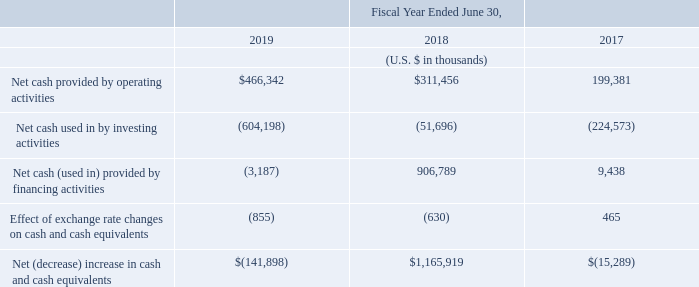B. Liquidity and Capital Resources
As of June 30, 2019, we had cash and cash equivalents totaling $1.3 billion, short-term investments totaling $445.0 million and trade receivables totaling $82.5 million. Since our inception, we have primarily financed our operations through cash flows generated by operations.
Our cash flows from operating activities, investing activities, and financing activities for the fiscal years ended 2019, 2018 and 2017 were as follows:
We believe that our existing cash and cash equivalents, together with cash generated from operations, will be sufficient to meet our anticipated cash needs for at least the next 12 months. Our future capital requirements will depend on many factors including our growth rate, the timing and extent of spend on research and development efforts, employee headcount, marketing and sales activities, acquisitions of additional businesses and technologies, the timing and extent of exchange of the Notes for payments of cash, the introduction of new software and services offerings, enhancements to our existing software and services offerings and the continued market acceptance of our products.
Cash provided by operating activities has historically been affected by the amount of net income (loss) adjusted for non-cash expense items such as non-coupon impact related to the Notes and capped calls, depreciation and amortization and expense associated with share-based awards, the timing of employee-related costs such as bonus payments, collections from our customers, which is our largest source of operating cash flows, and changes in other working capital accounts.
Accounts impacting working capital consist of trade receivables, prepaid expenses and other current assets, current derivative assets, trade and other payables, provisions, current derivative liabilities, current portion of our Notes and other current liabilities. Our working capital may be impacted by various factors in future periods, such as billings to customers for subscriptions, licenses and maintenance services and the subsequent collection of those billings or the amount and timing of certain expenditures.
Net cash provided by operating activities was $466.3 million for the fiscal year ended June 30, 2019, as a result of $605.6 million in loss before income tax expense adjusted by non-cash charges including the loss of marking to fair value of the embedded exchange feature of the Notes and related capped call transactions of $533.9 million, depreciation and amortization of $70.2 million, share-based payment expense of $257.8 million and debt discount and issuance cost amortization of $33.9 million. The net increase of $169.0 million from our operating assets and liabilities was primarily attributable to a $122.5 million increase in our deferred revenue as a result of increased sales of subscriptions and renewals of maintenance contracts and a $75.6 million increase in trade and other payables, provisions and other non-current liabilities, offset by a $30.2 million increase in trade receivables. Net cash provided by operating activities was also impacted by tax refunds received, net of income tax paid of $7.0 million.
Net cash provided by operating activities was $311.5 million for the fiscal year ended June 30, 2018, as a result of $58.1 million in loss before income tax expense adjusted by non-cash charges including the loss of marking to fair value of the embedded exchange feature of the Notes and related capped call transactions of $12.4 million, depreciation and amortization of $79.4 million, share-based payment expense of $162.9 million and debt discount and issuance cost amortization of $7.5 million. The net increase of $113.1 million from our operating assets and liabilities was primarily attributable to a $97.7 million increase in our deferred revenue as a result of increased sales of subscriptions and renewals of maintenance contracts, a $43.5 million increase in trade and other payables, provisions and other noncurrent liabilities, offset by a $19.6 million increase in trade receivables and a $8.4 million increase in prepaid expenses and other current and non-current assets. Net cash provided by operating activities was also impacted by income taxes paid, net of refunds, of $4.2 million.
Net cash used in investing activities during the fiscal year ended June 30, 2019 was $604.2 million. This was primarily related to cash paid for business combinations, net of cash acquired, totaling $418.6 million, purchases of investments totaling $648.0 million and purchases of property and equipment totaling $44.2 million to support the growth of our business, including hardware, equipment and leasehold improvements, offset by cash received from the maturing of investments which totaled $485.0 million and proceeds from sales of investments of $20.5 million.
Net cash used in investing activities during the fiscal year ended June 30, 2018 was $51.7 million. This was primarily related to purchases of investments totaling $347.8 million and purchases of property and equipment totaling $30.2 million to support the growth of our business, including hardware, equipment and leasehold improvements, offset by cash received from the maturing of investments which totaled $206.1 million and proceeds from sales of investments of $123.9 million.
Net cash used in financing activities for the fiscal year ended June 30, 2019 was $3.2 million and was primarily related to coupon interest payments on the Notes of $6.3 million, offset by proceeds from exercises of employee share options of $3.5 million.
Net cash provided by financing activities for the fiscal year ended June 30, 2018 was $906.8 million and was primarily related to proceeds from the issuance of our Notes of $990.5 million offset by the purchase of the capped calls for $87.7 million.
As of June 30, 2019, what is the amount of cash and cash equivalents? $1.3 billion. As of June 30, 2019, what is the amount of trade receivables? $82.5 million. What is the net cash used in investing activities in fiscal year ended 2019?
Answer scale should be: thousand. (604,198). What is the difference in net cash provided by operating activities between fiscal year ended 2018 and 2019?
Answer scale should be: thousand. 466,342-311,456
Answer: 154886. What is the average net cash used in by investing activities for fiscal years 2017-2019?
Answer scale should be: thousand. -(604,198+51,696+224,573)/3
Answer: -293489. What is the percentage change of net cash provided by operating activities between fiscal year 2017 to 2018?
Answer scale should be: percent. (311,456-199,381)/199,381
Answer: 56.21. 